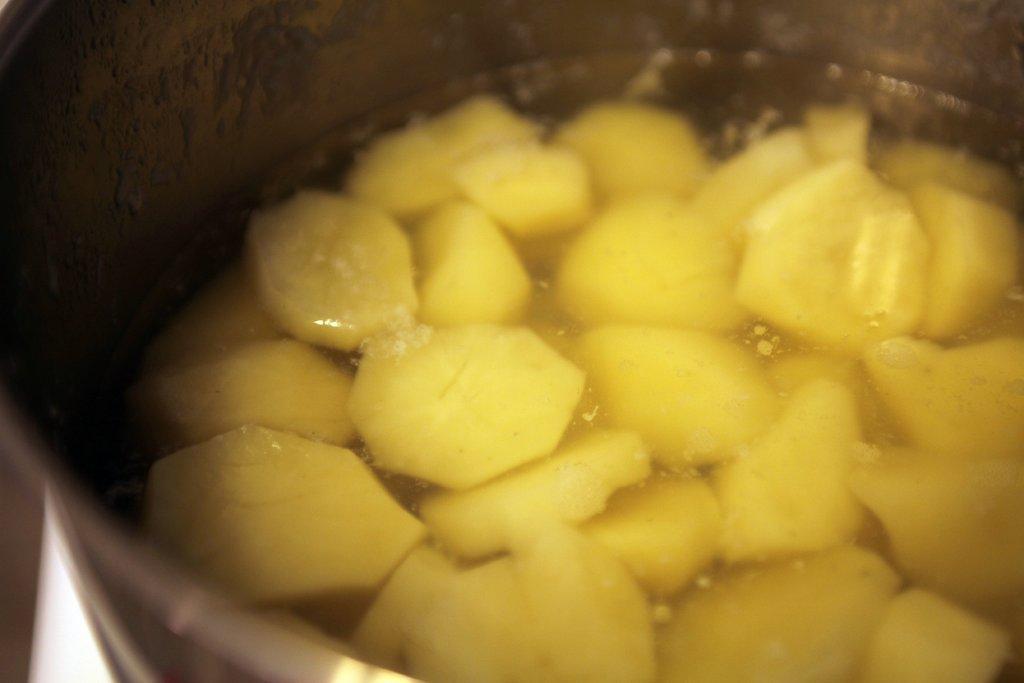Can you describe this image briefly? We can see slices of a food item in the water in a cup. 